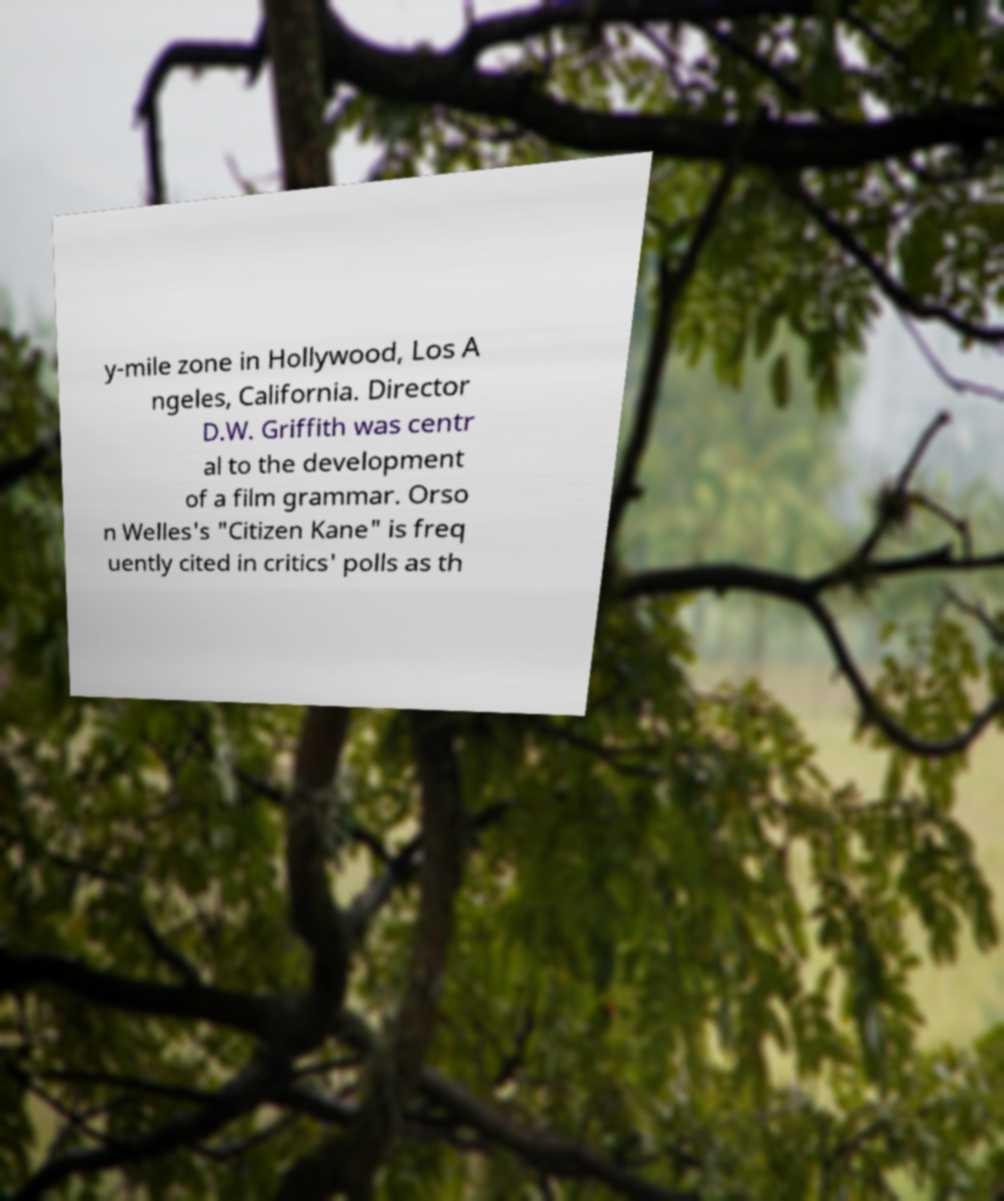Please identify and transcribe the text found in this image. y-mile zone in Hollywood, Los A ngeles, California. Director D.W. Griffith was centr al to the development of a film grammar. Orso n Welles's "Citizen Kane" is freq uently cited in critics' polls as th 